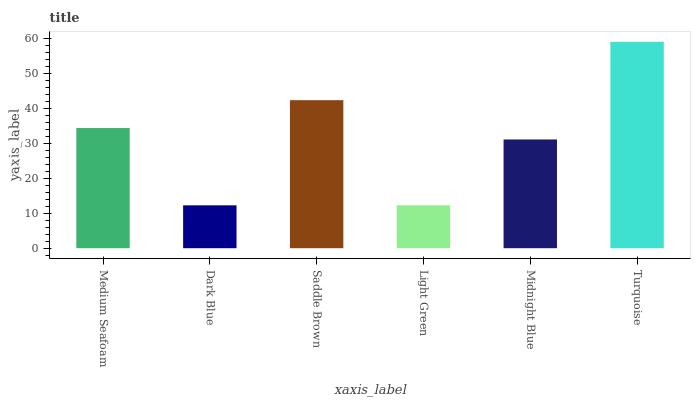Is Dark Blue the minimum?
Answer yes or no. Yes. Is Turquoise the maximum?
Answer yes or no. Yes. Is Saddle Brown the minimum?
Answer yes or no. No. Is Saddle Brown the maximum?
Answer yes or no. No. Is Saddle Brown greater than Dark Blue?
Answer yes or no. Yes. Is Dark Blue less than Saddle Brown?
Answer yes or no. Yes. Is Dark Blue greater than Saddle Brown?
Answer yes or no. No. Is Saddle Brown less than Dark Blue?
Answer yes or no. No. Is Medium Seafoam the high median?
Answer yes or no. Yes. Is Midnight Blue the low median?
Answer yes or no. Yes. Is Dark Blue the high median?
Answer yes or no. No. Is Saddle Brown the low median?
Answer yes or no. No. 